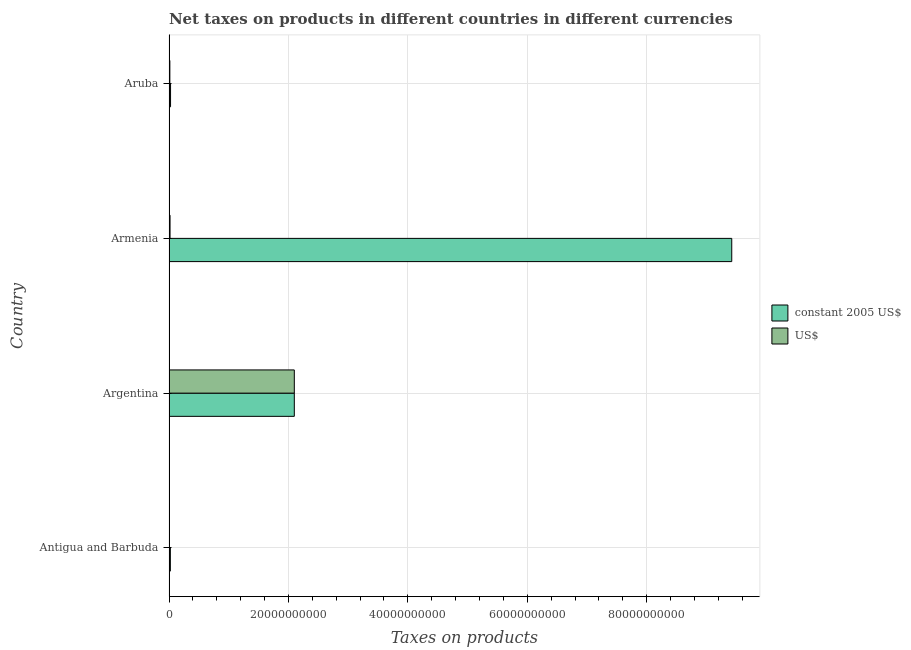How many different coloured bars are there?
Provide a succinct answer. 2. Are the number of bars on each tick of the Y-axis equal?
Provide a short and direct response. Yes. How many bars are there on the 2nd tick from the top?
Make the answer very short. 2. What is the label of the 1st group of bars from the top?
Provide a succinct answer. Aruba. What is the net taxes in constant 2005 us$ in Antigua and Barbuda?
Offer a very short reply. 2.27e+08. Across all countries, what is the maximum net taxes in constant 2005 us$?
Keep it short and to the point. 9.42e+1. Across all countries, what is the minimum net taxes in constant 2005 us$?
Give a very brief answer. 2.27e+08. In which country was the net taxes in constant 2005 us$ maximum?
Your answer should be very brief. Armenia. In which country was the net taxes in constant 2005 us$ minimum?
Your response must be concise. Antigua and Barbuda. What is the total net taxes in us$ in the graph?
Provide a short and direct response. 2.14e+1. What is the difference between the net taxes in us$ in Antigua and Barbuda and that in Aruba?
Keep it short and to the point. -6.05e+07. What is the difference between the net taxes in us$ in Argentina and the net taxes in constant 2005 us$ in Antigua and Barbuda?
Offer a terse response. 2.08e+1. What is the average net taxes in constant 2005 us$ per country?
Keep it short and to the point. 2.89e+1. What is the difference between the net taxes in constant 2005 us$ and net taxes in us$ in Armenia?
Keep it short and to the point. 9.41e+1. In how many countries, is the net taxes in constant 2005 us$ greater than 24000000000 units?
Ensure brevity in your answer.  1. What is the ratio of the net taxes in us$ in Argentina to that in Aruba?
Your answer should be compact. 145.17. Is the difference between the net taxes in constant 2005 us$ in Argentina and Armenia greater than the difference between the net taxes in us$ in Argentina and Armenia?
Your answer should be very brief. No. What is the difference between the highest and the second highest net taxes in us$?
Your response must be concise. 2.08e+1. What is the difference between the highest and the lowest net taxes in us$?
Offer a terse response. 2.09e+1. In how many countries, is the net taxes in us$ greater than the average net taxes in us$ taken over all countries?
Provide a succinct answer. 1. Is the sum of the net taxes in constant 2005 us$ in Armenia and Aruba greater than the maximum net taxes in us$ across all countries?
Your response must be concise. Yes. What does the 2nd bar from the top in Argentina represents?
Your answer should be compact. Constant 2005 us$. What does the 1st bar from the bottom in Antigua and Barbuda represents?
Offer a terse response. Constant 2005 us$. Are all the bars in the graph horizontal?
Make the answer very short. Yes. How many countries are there in the graph?
Make the answer very short. 4. What is the difference between two consecutive major ticks on the X-axis?
Your answer should be very brief. 2.00e+1. Where does the legend appear in the graph?
Your answer should be very brief. Center right. How are the legend labels stacked?
Make the answer very short. Vertical. What is the title of the graph?
Keep it short and to the point. Net taxes on products in different countries in different currencies. Does "Primary school" appear as one of the legend labels in the graph?
Your answer should be very brief. No. What is the label or title of the X-axis?
Your answer should be very brief. Taxes on products. What is the label or title of the Y-axis?
Give a very brief answer. Country. What is the Taxes on products in constant 2005 US$ in Antigua and Barbuda?
Your answer should be compact. 2.27e+08. What is the Taxes on products of US$ in Antigua and Barbuda?
Your answer should be very brief. 8.41e+07. What is the Taxes on products in constant 2005 US$ in Argentina?
Ensure brevity in your answer.  2.10e+1. What is the Taxes on products of US$ in Argentina?
Ensure brevity in your answer.  2.10e+1. What is the Taxes on products of constant 2005 US$ in Armenia?
Offer a terse response. 9.42e+1. What is the Taxes on products of US$ in Armenia?
Your answer should be compact. 1.75e+08. What is the Taxes on products of constant 2005 US$ in Aruba?
Make the answer very short. 2.59e+08. What is the Taxes on products in US$ in Aruba?
Give a very brief answer. 1.45e+08. Across all countries, what is the maximum Taxes on products in constant 2005 US$?
Provide a succinct answer. 9.42e+1. Across all countries, what is the maximum Taxes on products in US$?
Your answer should be compact. 2.10e+1. Across all countries, what is the minimum Taxes on products in constant 2005 US$?
Make the answer very short. 2.27e+08. Across all countries, what is the minimum Taxes on products of US$?
Offer a very short reply. 8.41e+07. What is the total Taxes on products in constant 2005 US$ in the graph?
Provide a succinct answer. 1.16e+11. What is the total Taxes on products in US$ in the graph?
Make the answer very short. 2.14e+1. What is the difference between the Taxes on products of constant 2005 US$ in Antigua and Barbuda and that in Argentina?
Ensure brevity in your answer.  -2.08e+1. What is the difference between the Taxes on products in US$ in Antigua and Barbuda and that in Argentina?
Your answer should be compact. -2.09e+1. What is the difference between the Taxes on products of constant 2005 US$ in Antigua and Barbuda and that in Armenia?
Keep it short and to the point. -9.40e+1. What is the difference between the Taxes on products in US$ in Antigua and Barbuda and that in Armenia?
Your answer should be compact. -9.06e+07. What is the difference between the Taxes on products of constant 2005 US$ in Antigua and Barbuda and that in Aruba?
Your answer should be very brief. -3.18e+07. What is the difference between the Taxes on products of US$ in Antigua and Barbuda and that in Aruba?
Ensure brevity in your answer.  -6.05e+07. What is the difference between the Taxes on products in constant 2005 US$ in Argentina and that in Armenia?
Provide a short and direct response. -7.33e+1. What is the difference between the Taxes on products of US$ in Argentina and that in Armenia?
Offer a terse response. 2.08e+1. What is the difference between the Taxes on products in constant 2005 US$ in Argentina and that in Aruba?
Keep it short and to the point. 2.07e+1. What is the difference between the Taxes on products in US$ in Argentina and that in Aruba?
Keep it short and to the point. 2.08e+1. What is the difference between the Taxes on products of constant 2005 US$ in Armenia and that in Aruba?
Provide a short and direct response. 9.40e+1. What is the difference between the Taxes on products in US$ in Armenia and that in Aruba?
Your response must be concise. 3.01e+07. What is the difference between the Taxes on products of constant 2005 US$ in Antigua and Barbuda and the Taxes on products of US$ in Argentina?
Keep it short and to the point. -2.08e+1. What is the difference between the Taxes on products in constant 2005 US$ in Antigua and Barbuda and the Taxes on products in US$ in Armenia?
Offer a terse response. 5.23e+07. What is the difference between the Taxes on products in constant 2005 US$ in Antigua and Barbuda and the Taxes on products in US$ in Aruba?
Make the answer very short. 8.24e+07. What is the difference between the Taxes on products of constant 2005 US$ in Argentina and the Taxes on products of US$ in Armenia?
Make the answer very short. 2.08e+1. What is the difference between the Taxes on products in constant 2005 US$ in Argentina and the Taxes on products in US$ in Aruba?
Offer a very short reply. 2.08e+1. What is the difference between the Taxes on products of constant 2005 US$ in Armenia and the Taxes on products of US$ in Aruba?
Make the answer very short. 9.41e+1. What is the average Taxes on products of constant 2005 US$ per country?
Ensure brevity in your answer.  2.89e+1. What is the average Taxes on products in US$ per country?
Give a very brief answer. 5.35e+09. What is the difference between the Taxes on products of constant 2005 US$ and Taxes on products of US$ in Antigua and Barbuda?
Provide a succinct answer. 1.43e+08. What is the difference between the Taxes on products in constant 2005 US$ and Taxes on products in US$ in Armenia?
Your response must be concise. 9.41e+1. What is the difference between the Taxes on products in constant 2005 US$ and Taxes on products in US$ in Aruba?
Make the answer very short. 1.14e+08. What is the ratio of the Taxes on products of constant 2005 US$ in Antigua and Barbuda to that in Argentina?
Make the answer very short. 0.01. What is the ratio of the Taxes on products of US$ in Antigua and Barbuda to that in Argentina?
Give a very brief answer. 0. What is the ratio of the Taxes on products in constant 2005 US$ in Antigua and Barbuda to that in Armenia?
Ensure brevity in your answer.  0. What is the ratio of the Taxes on products in US$ in Antigua and Barbuda to that in Armenia?
Provide a succinct answer. 0.48. What is the ratio of the Taxes on products in constant 2005 US$ in Antigua and Barbuda to that in Aruba?
Your answer should be compact. 0.88. What is the ratio of the Taxes on products of US$ in Antigua and Barbuda to that in Aruba?
Give a very brief answer. 0.58. What is the ratio of the Taxes on products of constant 2005 US$ in Argentina to that in Armenia?
Make the answer very short. 0.22. What is the ratio of the Taxes on products of US$ in Argentina to that in Armenia?
Offer a terse response. 120.14. What is the ratio of the Taxes on products of constant 2005 US$ in Argentina to that in Aruba?
Make the answer very short. 81.1. What is the ratio of the Taxes on products of US$ in Argentina to that in Aruba?
Keep it short and to the point. 145.17. What is the ratio of the Taxes on products of constant 2005 US$ in Armenia to that in Aruba?
Offer a terse response. 364.2. What is the ratio of the Taxes on products in US$ in Armenia to that in Aruba?
Your answer should be very brief. 1.21. What is the difference between the highest and the second highest Taxes on products of constant 2005 US$?
Provide a succinct answer. 7.33e+1. What is the difference between the highest and the second highest Taxes on products in US$?
Ensure brevity in your answer.  2.08e+1. What is the difference between the highest and the lowest Taxes on products in constant 2005 US$?
Your answer should be compact. 9.40e+1. What is the difference between the highest and the lowest Taxes on products of US$?
Ensure brevity in your answer.  2.09e+1. 